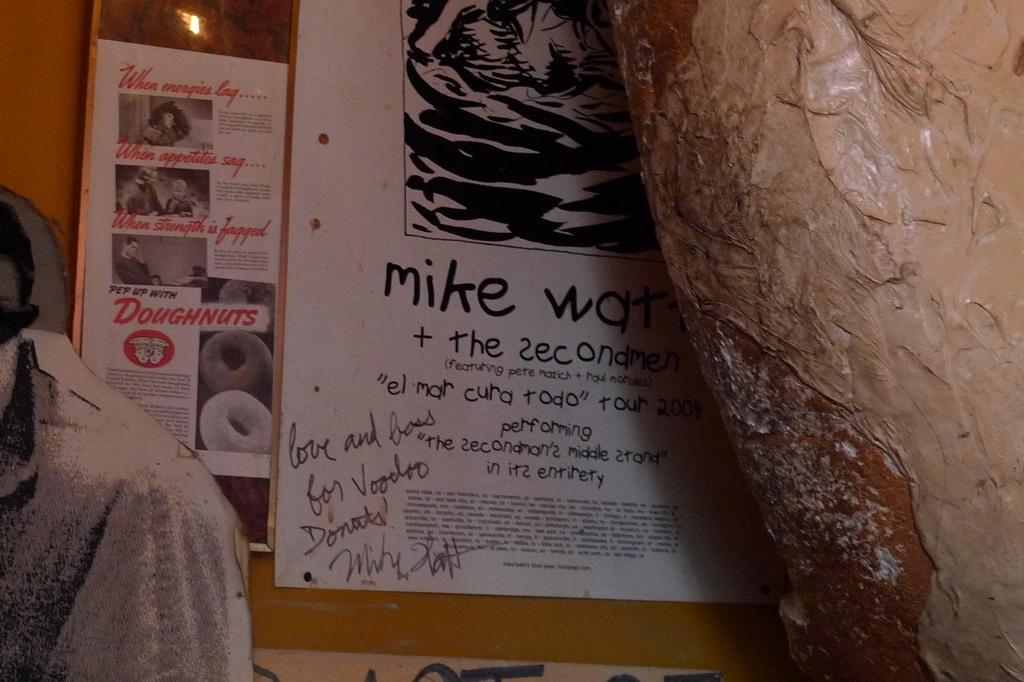Can you describe this image briefly? In this image we can see posts on the wall and other objects. On the posters we can see some text, pictures of persons, and doughnuts. 